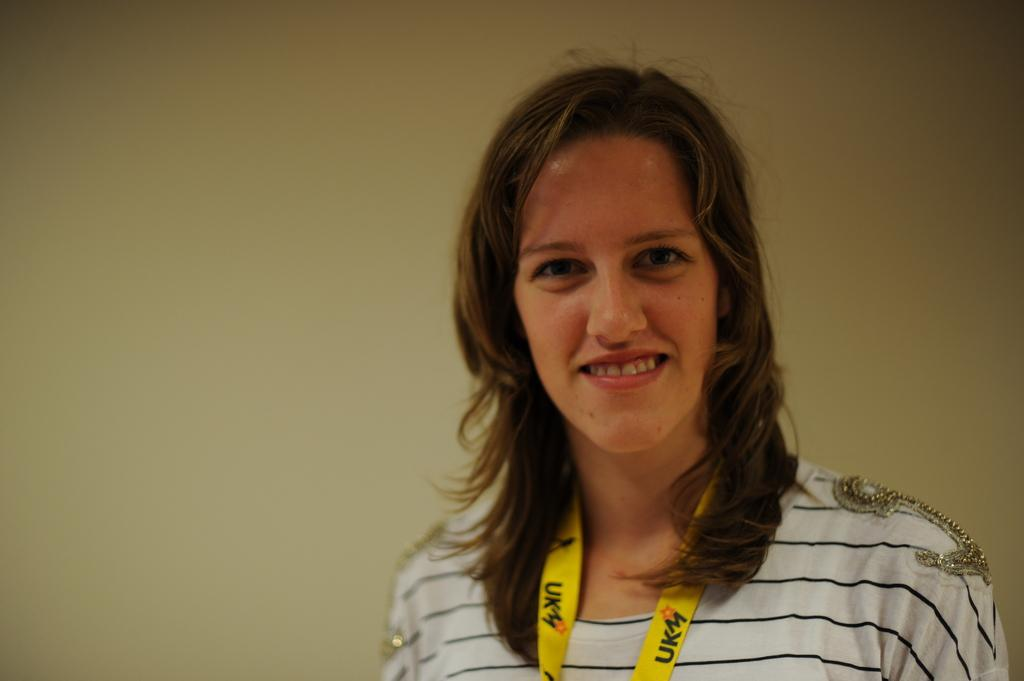What is the main subject of the image? The main subject of the image is a woman. Can you describe any specific features or accessories the woman has? Yes, the woman has a tag. What is the woman's facial expression in the image? The woman is smiling. What can be seen in the background of the image? There is a wall in the background of the image. What type of kettle is being used to improve the woman's health in the image? There is no kettle or reference to health improvement in the image. What type of meat is the woman holding in the image? There is no meat present in the image. 